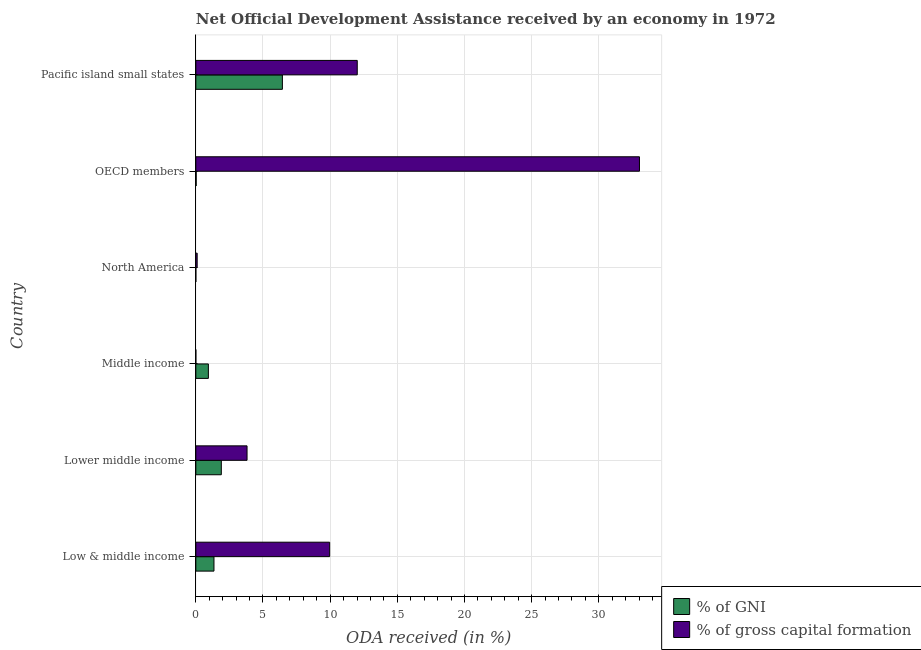How many different coloured bars are there?
Give a very brief answer. 2. How many groups of bars are there?
Your answer should be compact. 6. Are the number of bars per tick equal to the number of legend labels?
Offer a terse response. Yes. Are the number of bars on each tick of the Y-axis equal?
Your answer should be compact. Yes. What is the oda received as percentage of gni in OECD members?
Provide a short and direct response. 0.03. Across all countries, what is the maximum oda received as percentage of gni?
Ensure brevity in your answer.  6.44. Across all countries, what is the minimum oda received as percentage of gross capital formation?
Keep it short and to the point. 3.17387172321993e-6. In which country was the oda received as percentage of gross capital formation maximum?
Your answer should be compact. OECD members. In which country was the oda received as percentage of gni minimum?
Give a very brief answer. North America. What is the total oda received as percentage of gross capital formation in the graph?
Keep it short and to the point. 58.93. What is the difference between the oda received as percentage of gross capital formation in Low & middle income and that in Pacific island small states?
Your response must be concise. -2.06. What is the difference between the oda received as percentage of gni in Pacific island small states and the oda received as percentage of gross capital formation in Middle income?
Offer a terse response. 6.44. What is the average oda received as percentage of gni per country?
Your answer should be compact. 1.77. What is the difference between the oda received as percentage of gross capital formation and oda received as percentage of gni in Middle income?
Provide a succinct answer. -0.93. In how many countries, is the oda received as percentage of gni greater than 21 %?
Offer a terse response. 0. What is the ratio of the oda received as percentage of gross capital formation in OECD members to that in Pacific island small states?
Your answer should be very brief. 2.75. Is the oda received as percentage of gni in Middle income less than that in OECD members?
Give a very brief answer. No. What is the difference between the highest and the second highest oda received as percentage of gross capital formation?
Give a very brief answer. 21.01. What is the difference between the highest and the lowest oda received as percentage of gni?
Your response must be concise. 6.44. Is the sum of the oda received as percentage of gross capital formation in Lower middle income and North America greater than the maximum oda received as percentage of gni across all countries?
Provide a short and direct response. No. What does the 2nd bar from the top in Lower middle income represents?
Your response must be concise. % of GNI. What does the 2nd bar from the bottom in OECD members represents?
Your answer should be compact. % of gross capital formation. Are all the bars in the graph horizontal?
Offer a very short reply. Yes. What is the difference between two consecutive major ticks on the X-axis?
Provide a succinct answer. 5. Are the values on the major ticks of X-axis written in scientific E-notation?
Your response must be concise. No. Does the graph contain any zero values?
Your response must be concise. No. Does the graph contain grids?
Offer a very short reply. Yes. Where does the legend appear in the graph?
Provide a short and direct response. Bottom right. What is the title of the graph?
Give a very brief answer. Net Official Development Assistance received by an economy in 1972. Does "Female entrants" appear as one of the legend labels in the graph?
Ensure brevity in your answer.  No. What is the label or title of the X-axis?
Give a very brief answer. ODA received (in %). What is the ODA received (in %) of % of GNI in Low & middle income?
Your response must be concise. 1.35. What is the ODA received (in %) in % of gross capital formation in Low & middle income?
Give a very brief answer. 9.96. What is the ODA received (in %) of % of GNI in Lower middle income?
Provide a short and direct response. 1.9. What is the ODA received (in %) of % of gross capital formation in Lower middle income?
Make the answer very short. 3.81. What is the ODA received (in %) in % of GNI in Middle income?
Your answer should be very brief. 0.93. What is the ODA received (in %) of % of gross capital formation in Middle income?
Make the answer very short. 3.17387172321993e-6. What is the ODA received (in %) in % of GNI in North America?
Your answer should be very brief. 7.16450123346151e-7. What is the ODA received (in %) in % of gross capital formation in North America?
Provide a succinct answer. 0.1. What is the ODA received (in %) in % of GNI in OECD members?
Offer a terse response. 0.03. What is the ODA received (in %) in % of gross capital formation in OECD members?
Provide a short and direct response. 33.03. What is the ODA received (in %) in % of GNI in Pacific island small states?
Your answer should be very brief. 6.44. What is the ODA received (in %) of % of gross capital formation in Pacific island small states?
Your response must be concise. 12.02. Across all countries, what is the maximum ODA received (in %) of % of GNI?
Make the answer very short. 6.44. Across all countries, what is the maximum ODA received (in %) in % of gross capital formation?
Give a very brief answer. 33.03. Across all countries, what is the minimum ODA received (in %) of % of GNI?
Keep it short and to the point. 7.16450123346151e-7. Across all countries, what is the minimum ODA received (in %) in % of gross capital formation?
Your response must be concise. 3.17387172321993e-6. What is the total ODA received (in %) in % of GNI in the graph?
Keep it short and to the point. 10.65. What is the total ODA received (in %) in % of gross capital formation in the graph?
Ensure brevity in your answer.  58.93. What is the difference between the ODA received (in %) of % of GNI in Low & middle income and that in Lower middle income?
Provide a short and direct response. -0.55. What is the difference between the ODA received (in %) in % of gross capital formation in Low & middle income and that in Lower middle income?
Keep it short and to the point. 6.15. What is the difference between the ODA received (in %) of % of GNI in Low & middle income and that in Middle income?
Ensure brevity in your answer.  0.42. What is the difference between the ODA received (in %) in % of gross capital formation in Low & middle income and that in Middle income?
Keep it short and to the point. 9.96. What is the difference between the ODA received (in %) of % of GNI in Low & middle income and that in North America?
Offer a very short reply. 1.35. What is the difference between the ODA received (in %) of % of gross capital formation in Low & middle income and that in North America?
Offer a terse response. 9.86. What is the difference between the ODA received (in %) of % of GNI in Low & middle income and that in OECD members?
Provide a short and direct response. 1.32. What is the difference between the ODA received (in %) of % of gross capital formation in Low & middle income and that in OECD members?
Ensure brevity in your answer.  -23.07. What is the difference between the ODA received (in %) of % of GNI in Low & middle income and that in Pacific island small states?
Keep it short and to the point. -5.09. What is the difference between the ODA received (in %) of % of gross capital formation in Low & middle income and that in Pacific island small states?
Ensure brevity in your answer.  -2.05. What is the difference between the ODA received (in %) of % of GNI in Lower middle income and that in Middle income?
Ensure brevity in your answer.  0.96. What is the difference between the ODA received (in %) of % of gross capital formation in Lower middle income and that in Middle income?
Keep it short and to the point. 3.81. What is the difference between the ODA received (in %) in % of GNI in Lower middle income and that in North America?
Provide a short and direct response. 1.9. What is the difference between the ODA received (in %) in % of gross capital formation in Lower middle income and that in North America?
Your answer should be very brief. 3.71. What is the difference between the ODA received (in %) of % of GNI in Lower middle income and that in OECD members?
Your answer should be compact. 1.87. What is the difference between the ODA received (in %) in % of gross capital formation in Lower middle income and that in OECD members?
Give a very brief answer. -29.22. What is the difference between the ODA received (in %) of % of GNI in Lower middle income and that in Pacific island small states?
Offer a terse response. -4.55. What is the difference between the ODA received (in %) in % of gross capital formation in Lower middle income and that in Pacific island small states?
Your response must be concise. -8.21. What is the difference between the ODA received (in %) in % of GNI in Middle income and that in North America?
Offer a terse response. 0.93. What is the difference between the ODA received (in %) in % of gross capital formation in Middle income and that in North America?
Offer a very short reply. -0.1. What is the difference between the ODA received (in %) of % of GNI in Middle income and that in OECD members?
Offer a very short reply. 0.91. What is the difference between the ODA received (in %) in % of gross capital formation in Middle income and that in OECD members?
Your answer should be compact. -33.03. What is the difference between the ODA received (in %) in % of GNI in Middle income and that in Pacific island small states?
Offer a terse response. -5.51. What is the difference between the ODA received (in %) of % of gross capital formation in Middle income and that in Pacific island small states?
Provide a short and direct response. -12.02. What is the difference between the ODA received (in %) of % of GNI in North America and that in OECD members?
Provide a succinct answer. -0.03. What is the difference between the ODA received (in %) in % of gross capital formation in North America and that in OECD members?
Your response must be concise. -32.93. What is the difference between the ODA received (in %) in % of GNI in North America and that in Pacific island small states?
Your response must be concise. -6.44. What is the difference between the ODA received (in %) of % of gross capital formation in North America and that in Pacific island small states?
Ensure brevity in your answer.  -11.92. What is the difference between the ODA received (in %) of % of GNI in OECD members and that in Pacific island small states?
Ensure brevity in your answer.  -6.42. What is the difference between the ODA received (in %) of % of gross capital formation in OECD members and that in Pacific island small states?
Offer a very short reply. 21.01. What is the difference between the ODA received (in %) of % of GNI in Low & middle income and the ODA received (in %) of % of gross capital formation in Lower middle income?
Offer a terse response. -2.46. What is the difference between the ODA received (in %) in % of GNI in Low & middle income and the ODA received (in %) in % of gross capital formation in Middle income?
Your response must be concise. 1.35. What is the difference between the ODA received (in %) in % of GNI in Low & middle income and the ODA received (in %) in % of gross capital formation in North America?
Provide a succinct answer. 1.25. What is the difference between the ODA received (in %) in % of GNI in Low & middle income and the ODA received (in %) in % of gross capital formation in OECD members?
Your answer should be very brief. -31.68. What is the difference between the ODA received (in %) in % of GNI in Low & middle income and the ODA received (in %) in % of gross capital formation in Pacific island small states?
Provide a short and direct response. -10.67. What is the difference between the ODA received (in %) of % of GNI in Lower middle income and the ODA received (in %) of % of gross capital formation in Middle income?
Make the answer very short. 1.9. What is the difference between the ODA received (in %) in % of GNI in Lower middle income and the ODA received (in %) in % of gross capital formation in North America?
Make the answer very short. 1.8. What is the difference between the ODA received (in %) in % of GNI in Lower middle income and the ODA received (in %) in % of gross capital formation in OECD members?
Keep it short and to the point. -31.13. What is the difference between the ODA received (in %) of % of GNI in Lower middle income and the ODA received (in %) of % of gross capital formation in Pacific island small states?
Your answer should be compact. -10.12. What is the difference between the ODA received (in %) in % of GNI in Middle income and the ODA received (in %) in % of gross capital formation in North America?
Offer a terse response. 0.83. What is the difference between the ODA received (in %) in % of GNI in Middle income and the ODA received (in %) in % of gross capital formation in OECD members?
Make the answer very short. -32.1. What is the difference between the ODA received (in %) of % of GNI in Middle income and the ODA received (in %) of % of gross capital formation in Pacific island small states?
Your answer should be compact. -11.08. What is the difference between the ODA received (in %) of % of GNI in North America and the ODA received (in %) of % of gross capital formation in OECD members?
Your response must be concise. -33.03. What is the difference between the ODA received (in %) of % of GNI in North America and the ODA received (in %) of % of gross capital formation in Pacific island small states?
Your answer should be very brief. -12.02. What is the difference between the ODA received (in %) of % of GNI in OECD members and the ODA received (in %) of % of gross capital formation in Pacific island small states?
Your response must be concise. -11.99. What is the average ODA received (in %) of % of GNI per country?
Your answer should be compact. 1.78. What is the average ODA received (in %) of % of gross capital formation per country?
Provide a succinct answer. 9.82. What is the difference between the ODA received (in %) of % of GNI and ODA received (in %) of % of gross capital formation in Low & middle income?
Ensure brevity in your answer.  -8.61. What is the difference between the ODA received (in %) of % of GNI and ODA received (in %) of % of gross capital formation in Lower middle income?
Make the answer very short. -1.92. What is the difference between the ODA received (in %) of % of GNI and ODA received (in %) of % of gross capital formation in Middle income?
Ensure brevity in your answer.  0.93. What is the difference between the ODA received (in %) of % of GNI and ODA received (in %) of % of gross capital formation in North America?
Give a very brief answer. -0.1. What is the difference between the ODA received (in %) in % of GNI and ODA received (in %) in % of gross capital formation in OECD members?
Offer a very short reply. -33. What is the difference between the ODA received (in %) of % of GNI and ODA received (in %) of % of gross capital formation in Pacific island small states?
Offer a terse response. -5.57. What is the ratio of the ODA received (in %) of % of GNI in Low & middle income to that in Lower middle income?
Provide a succinct answer. 0.71. What is the ratio of the ODA received (in %) of % of gross capital formation in Low & middle income to that in Lower middle income?
Make the answer very short. 2.61. What is the ratio of the ODA received (in %) of % of GNI in Low & middle income to that in Middle income?
Keep it short and to the point. 1.45. What is the ratio of the ODA received (in %) in % of gross capital formation in Low & middle income to that in Middle income?
Your answer should be compact. 3.14e+06. What is the ratio of the ODA received (in %) in % of GNI in Low & middle income to that in North America?
Give a very brief answer. 1.88e+06. What is the ratio of the ODA received (in %) in % of gross capital formation in Low & middle income to that in North America?
Offer a terse response. 99.49. What is the ratio of the ODA received (in %) of % of GNI in Low & middle income to that in OECD members?
Offer a very short reply. 52.31. What is the ratio of the ODA received (in %) of % of gross capital formation in Low & middle income to that in OECD members?
Give a very brief answer. 0.3. What is the ratio of the ODA received (in %) of % of GNI in Low & middle income to that in Pacific island small states?
Your answer should be very brief. 0.21. What is the ratio of the ODA received (in %) in % of gross capital formation in Low & middle income to that in Pacific island small states?
Ensure brevity in your answer.  0.83. What is the ratio of the ODA received (in %) in % of GNI in Lower middle income to that in Middle income?
Provide a short and direct response. 2.03. What is the ratio of the ODA received (in %) of % of gross capital formation in Lower middle income to that in Middle income?
Your answer should be very brief. 1.20e+06. What is the ratio of the ODA received (in %) in % of GNI in Lower middle income to that in North America?
Your answer should be compact. 2.65e+06. What is the ratio of the ODA received (in %) of % of gross capital formation in Lower middle income to that in North America?
Keep it short and to the point. 38.07. What is the ratio of the ODA received (in %) of % of GNI in Lower middle income to that in OECD members?
Your answer should be compact. 73.51. What is the ratio of the ODA received (in %) of % of gross capital formation in Lower middle income to that in OECD members?
Provide a short and direct response. 0.12. What is the ratio of the ODA received (in %) in % of GNI in Lower middle income to that in Pacific island small states?
Make the answer very short. 0.29. What is the ratio of the ODA received (in %) of % of gross capital formation in Lower middle income to that in Pacific island small states?
Make the answer very short. 0.32. What is the ratio of the ODA received (in %) in % of GNI in Middle income to that in North America?
Make the answer very short. 1.30e+06. What is the ratio of the ODA received (in %) of % of gross capital formation in Middle income to that in North America?
Provide a succinct answer. 0. What is the ratio of the ODA received (in %) in % of GNI in Middle income to that in OECD members?
Provide a short and direct response. 36.19. What is the ratio of the ODA received (in %) of % of GNI in Middle income to that in Pacific island small states?
Your answer should be compact. 0.14. What is the ratio of the ODA received (in %) of % of gross capital formation in North America to that in OECD members?
Offer a terse response. 0. What is the ratio of the ODA received (in %) in % of gross capital formation in North America to that in Pacific island small states?
Provide a short and direct response. 0.01. What is the ratio of the ODA received (in %) of % of GNI in OECD members to that in Pacific island small states?
Your answer should be very brief. 0. What is the ratio of the ODA received (in %) of % of gross capital formation in OECD members to that in Pacific island small states?
Your answer should be compact. 2.75. What is the difference between the highest and the second highest ODA received (in %) of % of GNI?
Make the answer very short. 4.55. What is the difference between the highest and the second highest ODA received (in %) in % of gross capital formation?
Keep it short and to the point. 21.01. What is the difference between the highest and the lowest ODA received (in %) of % of GNI?
Make the answer very short. 6.44. What is the difference between the highest and the lowest ODA received (in %) of % of gross capital formation?
Keep it short and to the point. 33.03. 